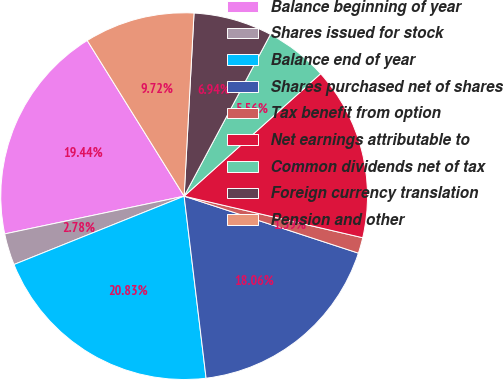<chart> <loc_0><loc_0><loc_500><loc_500><pie_chart><fcel>Balance beginning of year<fcel>Shares issued for stock<fcel>Balance end of year<fcel>Shares purchased net of shares<fcel>Tax benefit from option<fcel>Net earnings attributable to<fcel>Common dividends net of tax<fcel>Foreign currency translation<fcel>Pension and other<nl><fcel>19.44%<fcel>2.78%<fcel>20.83%<fcel>18.06%<fcel>1.39%<fcel>15.28%<fcel>5.56%<fcel>6.94%<fcel>9.72%<nl></chart> 